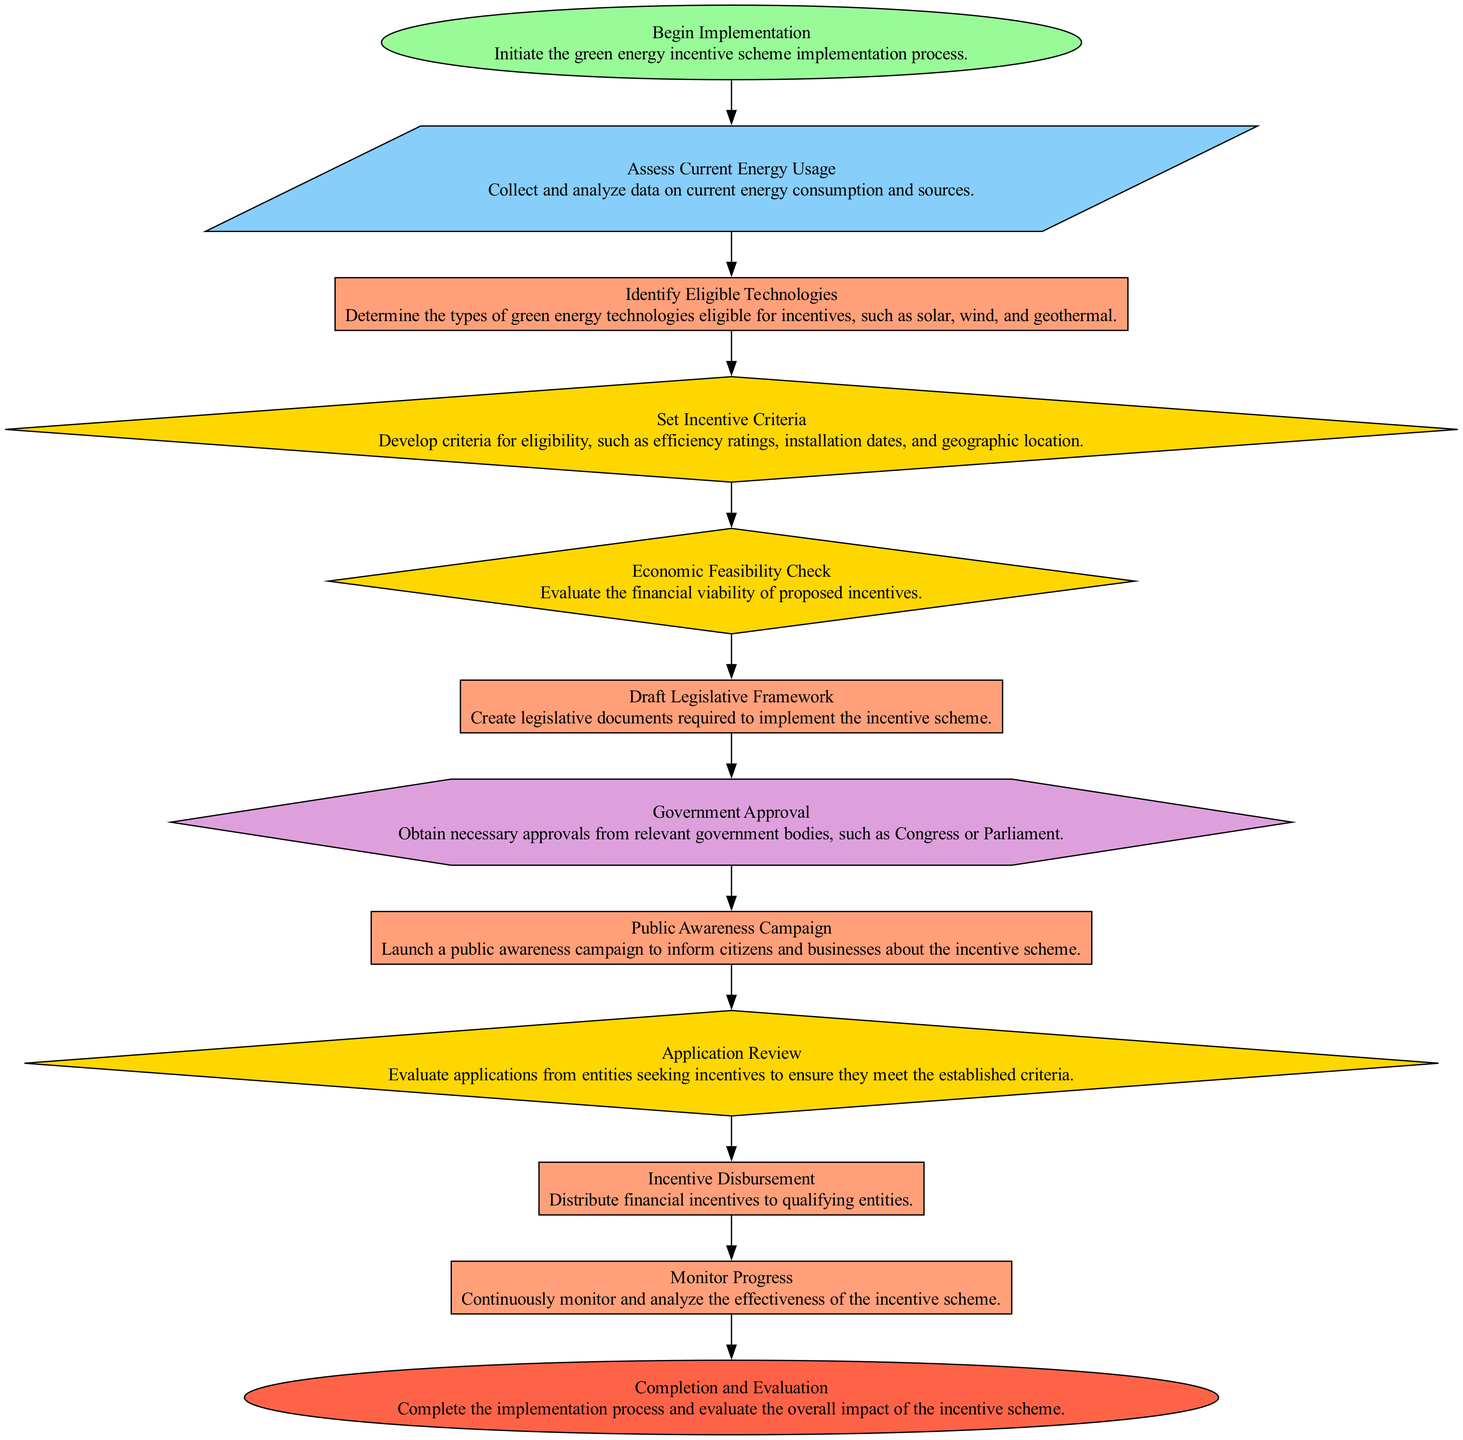What is the first step in the process? The first step is labeled "Begin Implementation," which initiates the process of implementing the green energy incentive scheme.
Answer: Begin Implementation How many decision nodes are there in the flowchart? The flowchart has three decision nodes: "Set Incentive Criteria," "Economic Feasibility Check," and "Application Review."
Answer: 3 What comes after "Draft Legislative Framework"? After "Draft Legislative Framework," the next step is "Government Approval." This indicates that government approval is required before proceeding further in the implementation process.
Answer: Government Approval Which node is designated for public outreach? The node labeled "Public Awareness Campaign" is specifically designated for public outreach to inform citizens and businesses about the incentive scheme.
Answer: Public Awareness Campaign What is the last node in the diagram? The last node in the diagram is called "Completion and Evaluation," marking the end of the implementation process and the evaluation of the scheme's impact.
Answer: Completion and Evaluation What type of node is "Economic Feasibility Check"? The "Economic Feasibility Check" is a decision node, used to evaluate the financial viability of proposed incentives before moving on with the process.
Answer: Decision After determining eligible technologies, what is the next step? After determining the eligible technologies, the next step is to "Set Incentive Criteria," establishing the conditions under which incentives will be granted.
Answer: Set Incentive Criteria How many total nodes are in the diagram? There are a total of twelve nodes in the diagram, including all types: start, input, process, decision, approval, and end nodes.
Answer: 12 Which node follows "Application Review"? The node that follows "Application Review" is "Incentive Disbursement," where financial incentives are allocated to the qualifying applicants.
Answer: Incentive Disbursement 